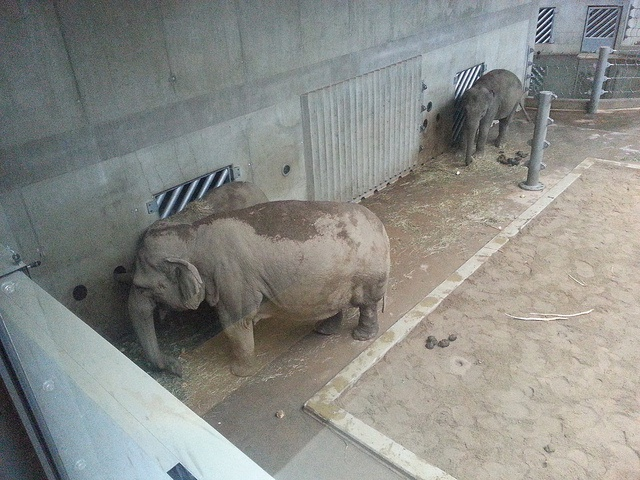Describe the objects in this image and their specific colors. I can see elephant in black, gray, and darkgray tones, elephant in black and gray tones, and elephant in black and gray tones in this image. 